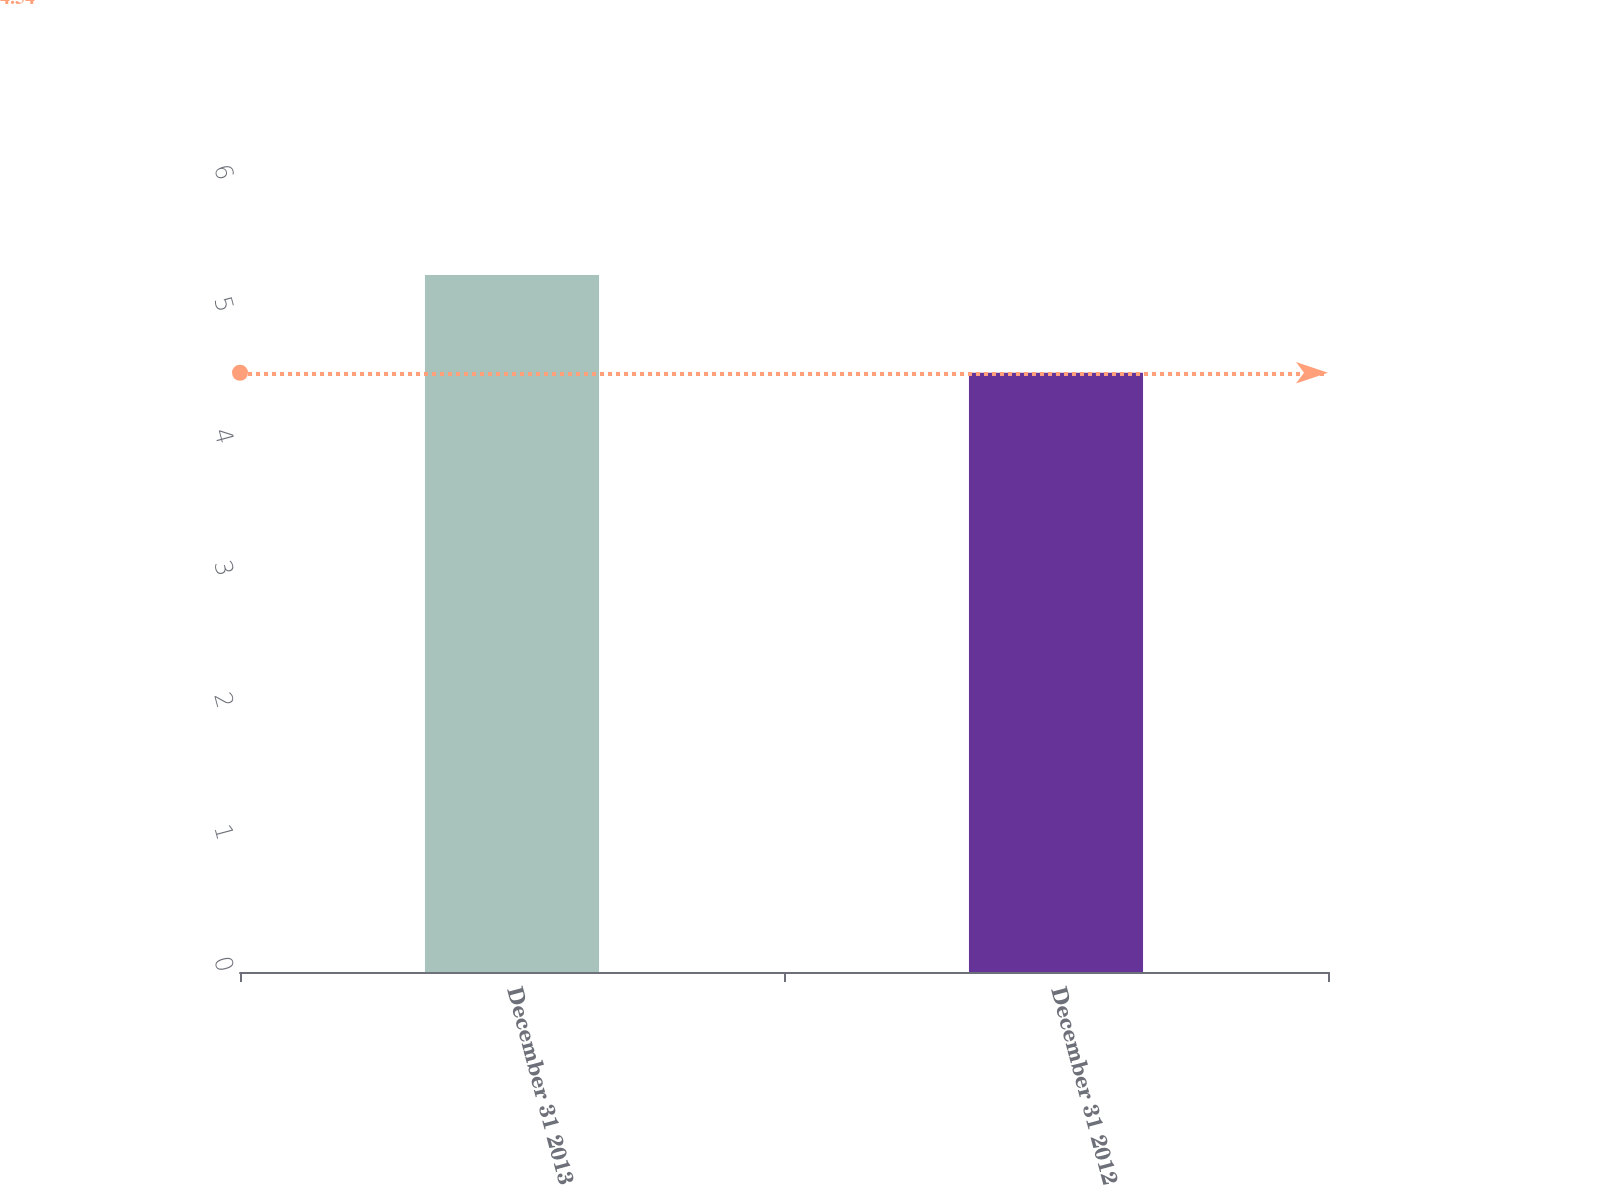Convert chart to OTSL. <chart><loc_0><loc_0><loc_500><loc_500><bar_chart><fcel>December 31 2013<fcel>December 31 2012<nl><fcel>5.28<fcel>4.54<nl></chart> 